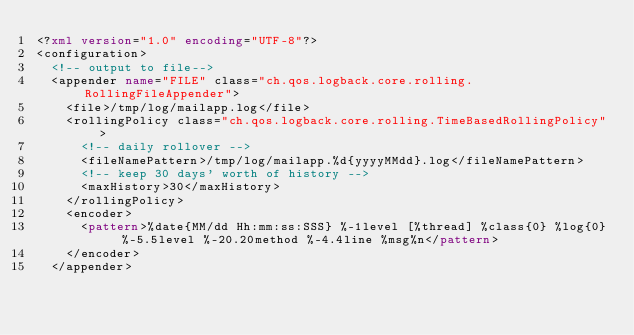<code> <loc_0><loc_0><loc_500><loc_500><_XML_><?xml version="1.0" encoding="UTF-8"?>
<configuration>
	<!-- output to file-->
	<appender name="FILE" class="ch.qos.logback.core.rolling.RollingFileAppender">
		<file>/tmp/log/mailapp.log</file>
		<rollingPolicy class="ch.qos.logback.core.rolling.TimeBasedRollingPolicy">
			<!-- daily rollover -->
			<fileNamePattern>/tmp/log/mailapp.%d{yyyyMMdd}.log</fileNamePattern>
			<!-- keep 30 days' worth of history -->
			<maxHistory>30</maxHistory>
		</rollingPolicy>
		<encoder>
			<pattern>%date{MM/dd Hh:mm:ss:SSS} %-1level [%thread] %class{0} %log{0} %-5.5level %-20.20method %-4.4line %msg%n</pattern>
		</encoder>
	</appender>
</code> 